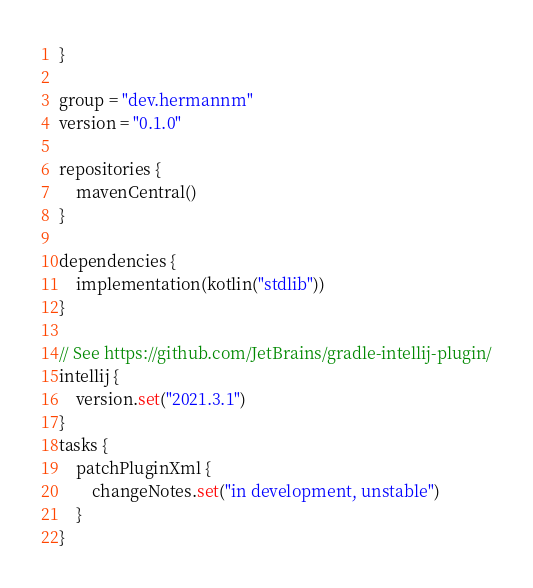<code> <loc_0><loc_0><loc_500><loc_500><_Kotlin_>}

group = "dev.hermannm"
version = "0.1.0"

repositories {
    mavenCentral()
}

dependencies {
    implementation(kotlin("stdlib"))
}

// See https://github.com/JetBrains/gradle-intellij-plugin/
intellij {
    version.set("2021.3.1")
}
tasks {
    patchPluginXml {
        changeNotes.set("in development, unstable")
    }
}
</code> 